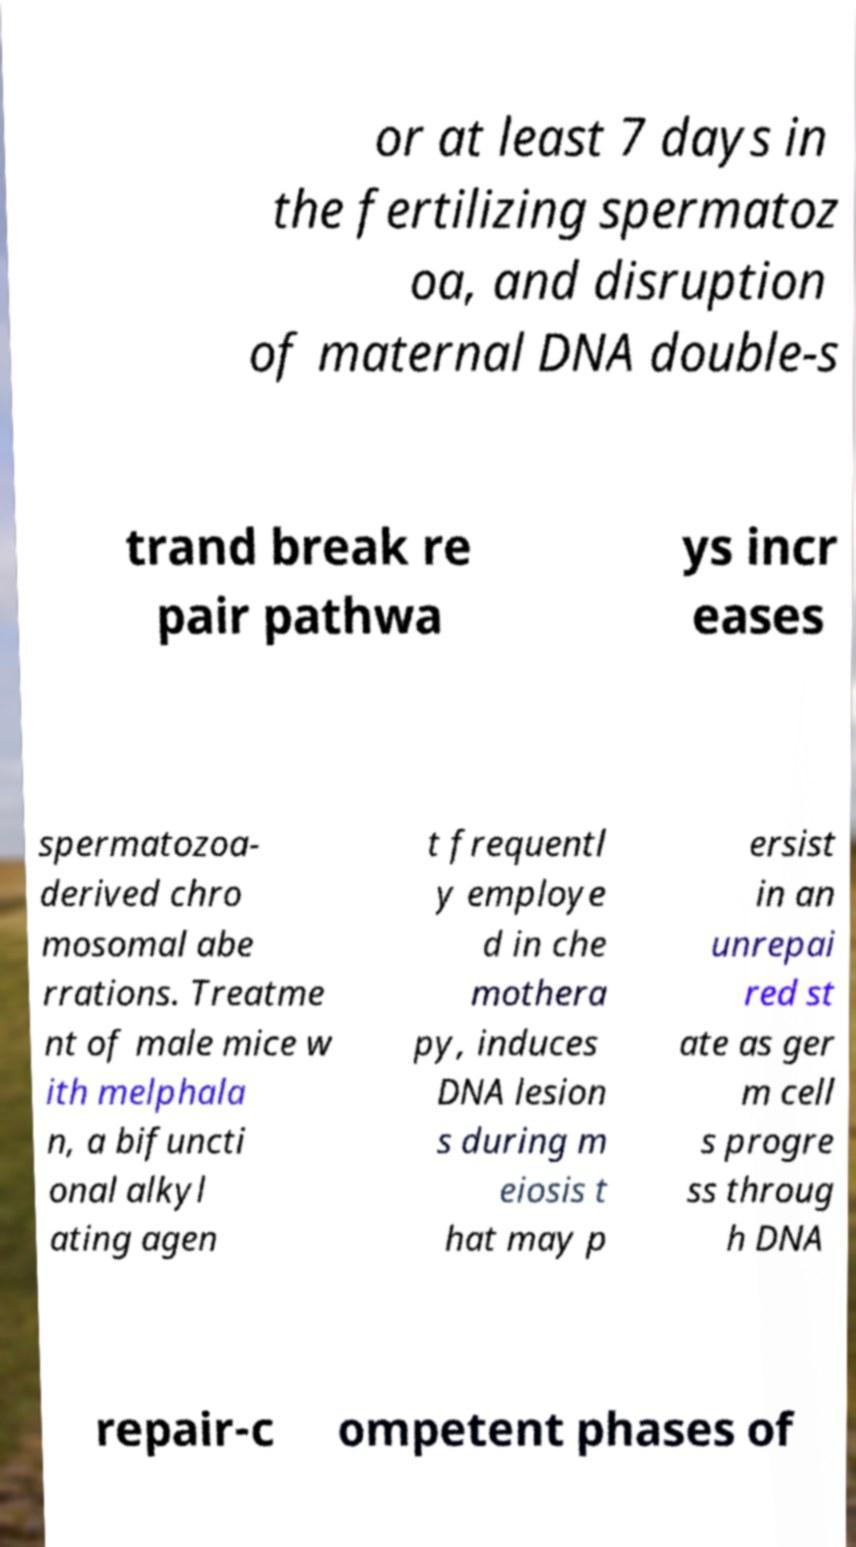Please identify and transcribe the text found in this image. or at least 7 days in the fertilizing spermatoz oa, and disruption of maternal DNA double-s trand break re pair pathwa ys incr eases spermatozoa- derived chro mosomal abe rrations. Treatme nt of male mice w ith melphala n, a bifuncti onal alkyl ating agen t frequentl y employe d in che mothera py, induces DNA lesion s during m eiosis t hat may p ersist in an unrepai red st ate as ger m cell s progre ss throug h DNA repair-c ompetent phases of 